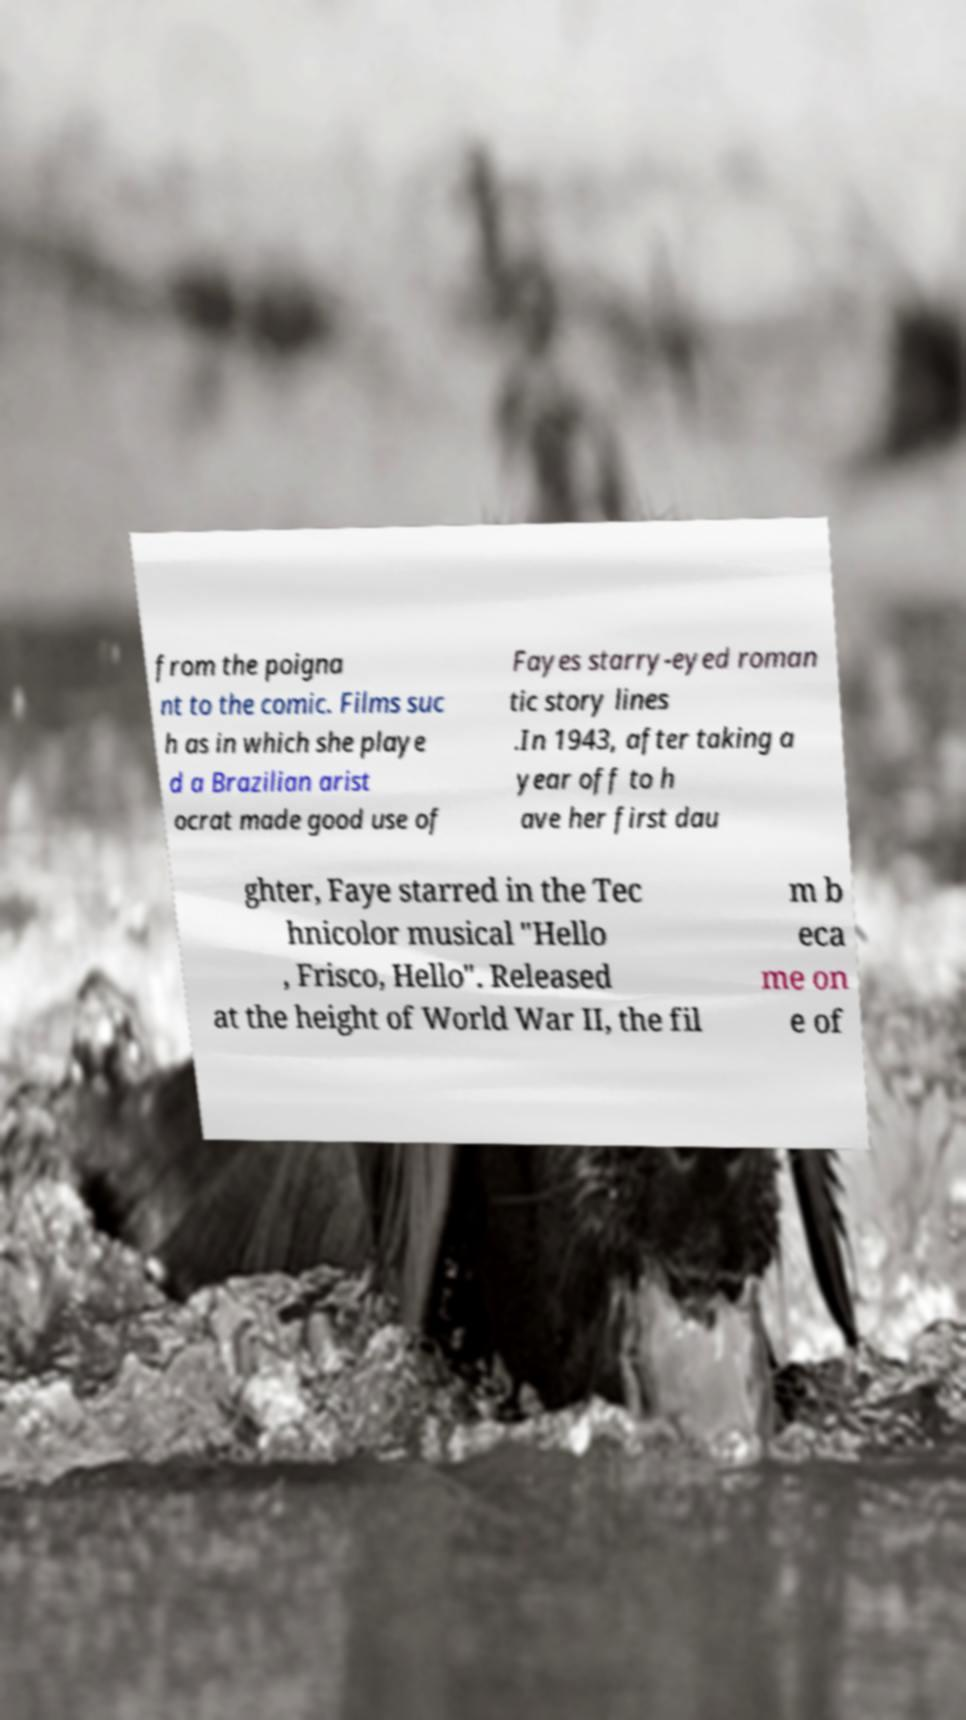Could you assist in decoding the text presented in this image and type it out clearly? from the poigna nt to the comic. Films suc h as in which she playe d a Brazilian arist ocrat made good use of Fayes starry-eyed roman tic story lines .In 1943, after taking a year off to h ave her first dau ghter, Faye starred in the Tec hnicolor musical "Hello , Frisco, Hello". Released at the height of World War II, the fil m b eca me on e of 